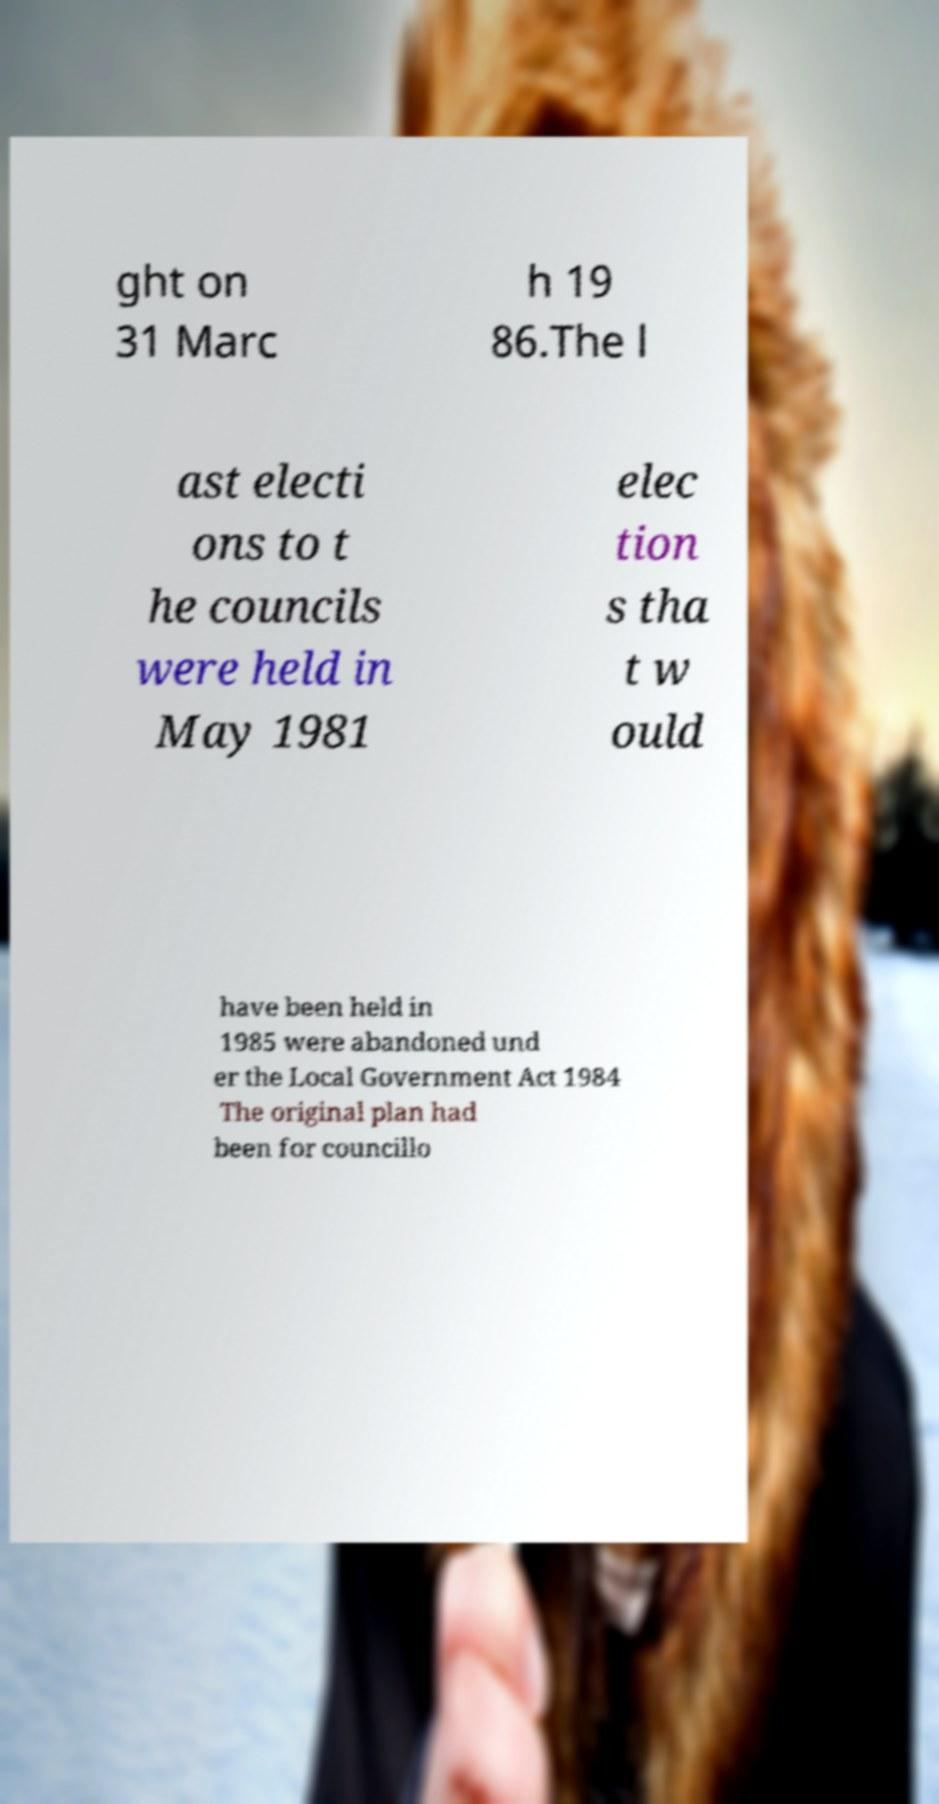Could you assist in decoding the text presented in this image and type it out clearly? ght on 31 Marc h 19 86.The l ast electi ons to t he councils were held in May 1981 elec tion s tha t w ould have been held in 1985 were abandoned und er the Local Government Act 1984 The original plan had been for councillo 